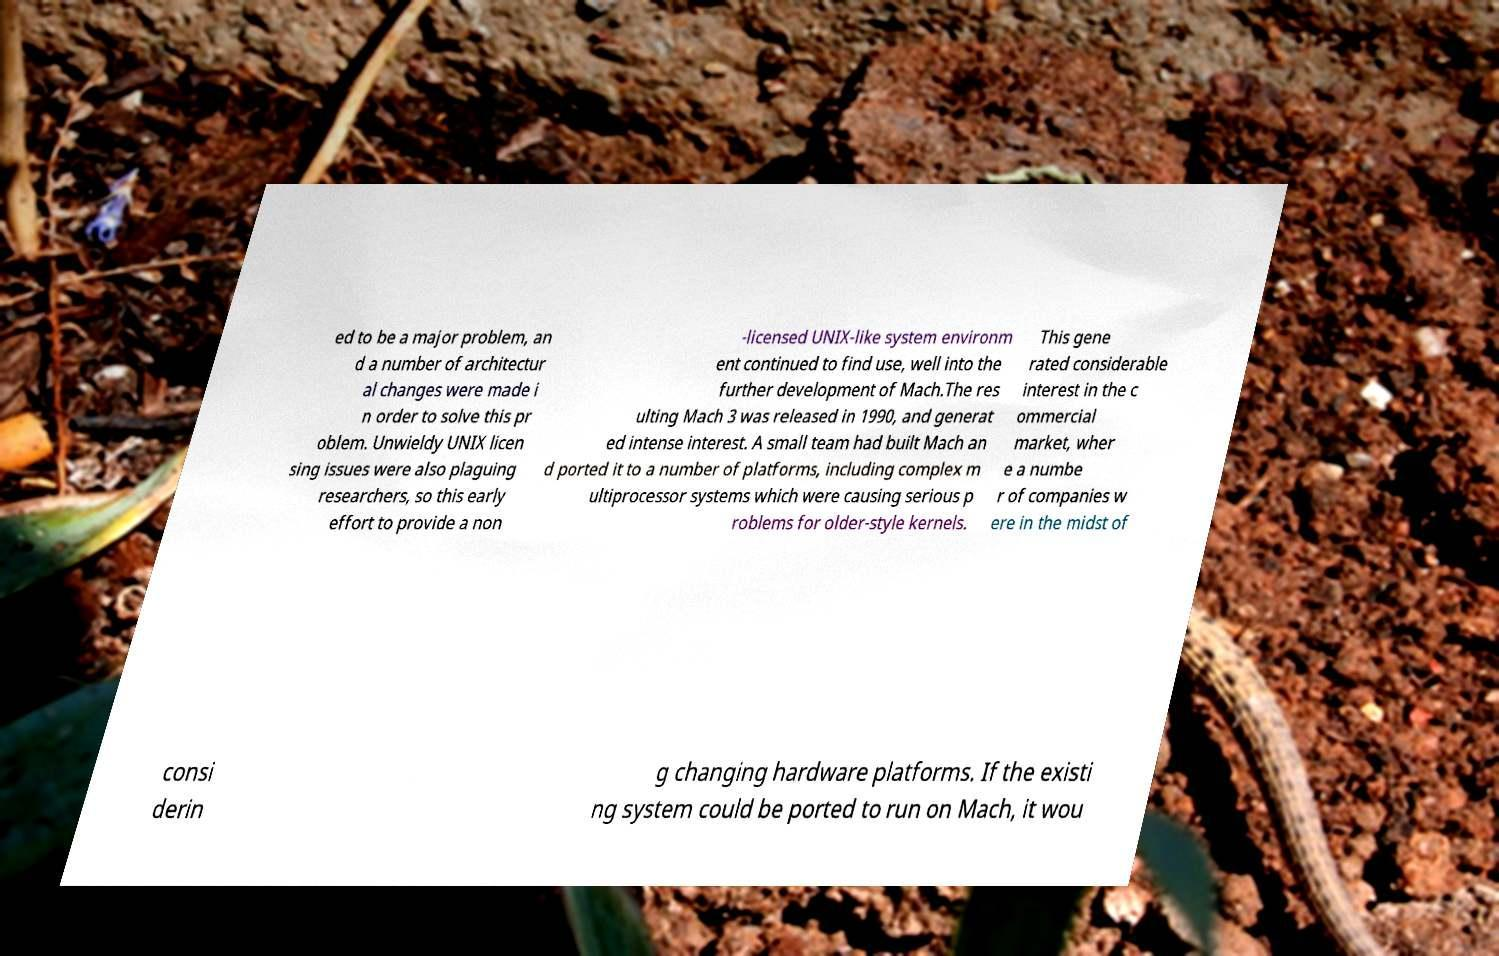Can you read and provide the text displayed in the image?This photo seems to have some interesting text. Can you extract and type it out for me? ed to be a major problem, an d a number of architectur al changes were made i n order to solve this pr oblem. Unwieldy UNIX licen sing issues were also plaguing researchers, so this early effort to provide a non -licensed UNIX-like system environm ent continued to find use, well into the further development of Mach.The res ulting Mach 3 was released in 1990, and generat ed intense interest. A small team had built Mach an d ported it to a number of platforms, including complex m ultiprocessor systems which were causing serious p roblems for older-style kernels. This gene rated considerable interest in the c ommercial market, wher e a numbe r of companies w ere in the midst of consi derin g changing hardware platforms. If the existi ng system could be ported to run on Mach, it wou 